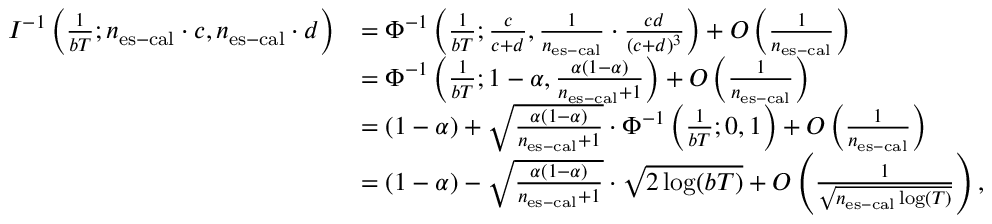<formula> <loc_0><loc_0><loc_500><loc_500>\begin{array} { r l } { I ^ { - 1 } \left ( \frac { 1 } { b T } ; n _ { e s - c a l } \cdot c , n _ { e s - c a l } \cdot d \right ) } & { = \Phi ^ { - 1 } \left ( \frac { 1 } { b T } ; \frac { c } { c + d } , \frac { 1 } { n _ { e s - c a l } } \cdot \frac { c d } { ( c + d ) ^ { 3 } } \right ) + O \left ( \frac { 1 } { n _ { e s - c a l } } \right ) } \\ & { = \Phi ^ { - 1 } \left ( \frac { 1 } { b T } ; 1 - \alpha , \frac { \alpha ( 1 - \alpha ) } { n _ { e s - c a l } + 1 } \right ) + O \left ( \frac { 1 } { n _ { e s - c a l } } \right ) } \\ & { = ( 1 - \alpha ) + \sqrt { \frac { \alpha ( 1 - \alpha ) } { n _ { e s - c a l } + 1 } } \cdot \Phi ^ { - 1 } \left ( \frac { 1 } { b T } ; 0 , 1 \right ) + O \left ( \frac { 1 } { n _ { e s - c a l } } \right ) } \\ & { = ( 1 - \alpha ) - \sqrt { \frac { \alpha ( 1 - \alpha ) } { n _ { e s - c a l } + 1 } } \cdot \sqrt { 2 \log ( b T ) } + O \left ( \frac { 1 } { \sqrt { n _ { e s - c a l } \log ( T ) } } \right ) , } \end{array}</formula> 